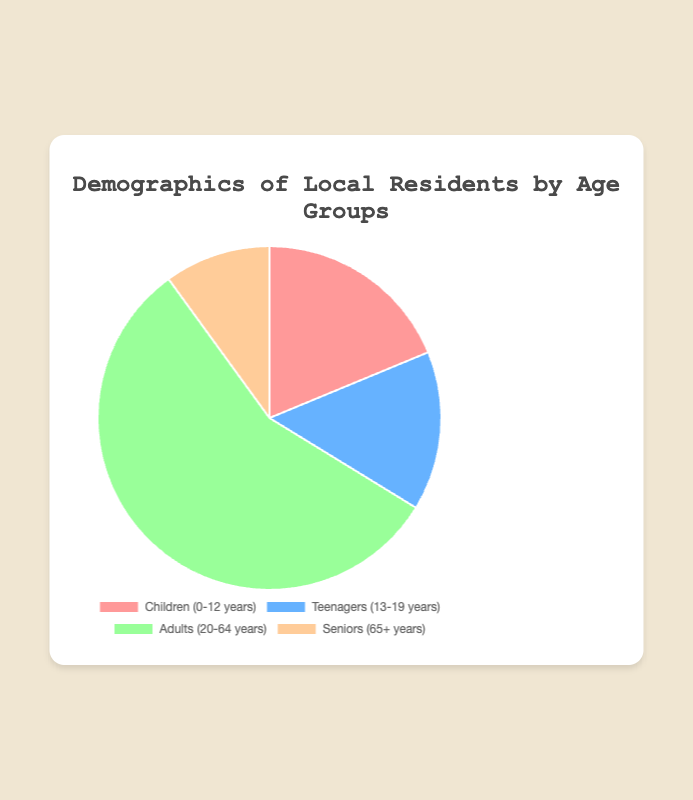What's the largest age group in the local demographics? The largest age group is found by identifying the segment with the highest value. Adults (20-64 years) have the highest value of 4500.
Answer: Adults Which age group has the smallest percentage of the population? The smallest percentage is identified by finding the segment with the lowest value. Seniors (65+ years) have the lowest value of 800.
Answer: Seniors What's the total number of residents under 20 years old? Sum the values for Children and Teenagers: 1500 (Children) + 1200 (Teenagers) = 2700.
Answer: 2700 By how many residents do Adults outnumber Teenagers? Subtract the number of Teenagers from Adults: 4500 (Adults) - 1200 (Teenagers) = 3300.
Answer: 3300 Which age group has more residents: Children or Seniors? Compare the values of Children and Seniors. Children have 1500 and Seniors have 800. 1500 is greater than 800.
Answer: Children What percentage of the population is made up of Seniors? The total population is the sum of all groups: 1500 (Children) + 1200 (Teenagers) + 4500 (Adults) + 800 (Seniors) = 8000. The percentage for Seniors is (800 / 8000) * 100 = 10%.
Answer: 10% How many more residents are there in the Adults group compared to the combined total of Children and Seniors? Sum Children and Seniors, then subtract from Adults: (1500 + 800) = 2300, then 4500 (Adults) - 2300 = 2200.
Answer: 2200 If the population increased by adding 500 more Children, what would be the new total population? Calculate the new total by adding 500 to Children and summing up all groups: 1500 + 500 + 1200 + 4500 + 800 = 8500.
Answer: 8500 What is the combined percentage of residents who are either Children or Teenagers? First, find the combined number of Children and Teenagers: 1500 + 1200 = 2700. Then find the percentage: (2700 / 8000) * 100 = 33.75%.
Answer: 33.75% Which age group segment is represented by the color blue in the pie chart? The Teenagers (13-19 years) segment is represented by the color blue.
Answer: Teenagers 